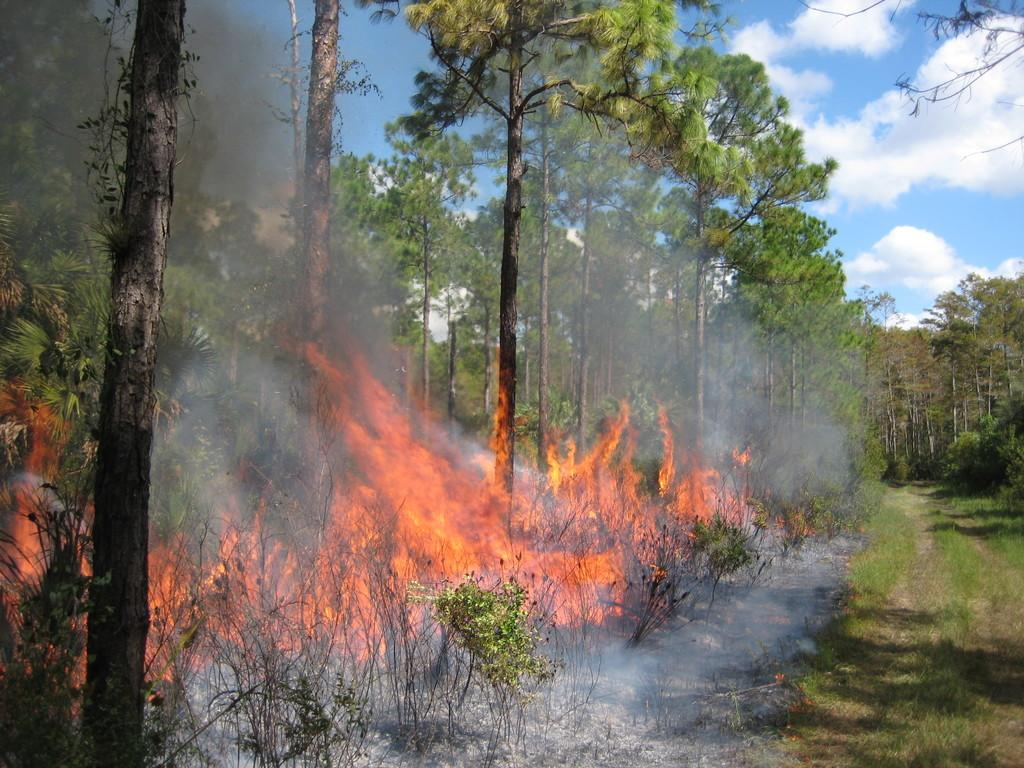What type of vegetation can be seen in the image? There is grass and plants in the image. What is the source of light in the image? The sky is visible in the image, and clouds are present. What natural element is present in the image? There are trees in the image. What is the unusual feature in the image? There is fire in the image. What type of invention is being demonstrated in the image? There is no invention being demonstrated in the image; it features grass, plants, trees, fire, and the sky. What is the impulse behind the fire in the image? The image does not provide information about the impulse behind the fire; it simply shows the presence of fire. 